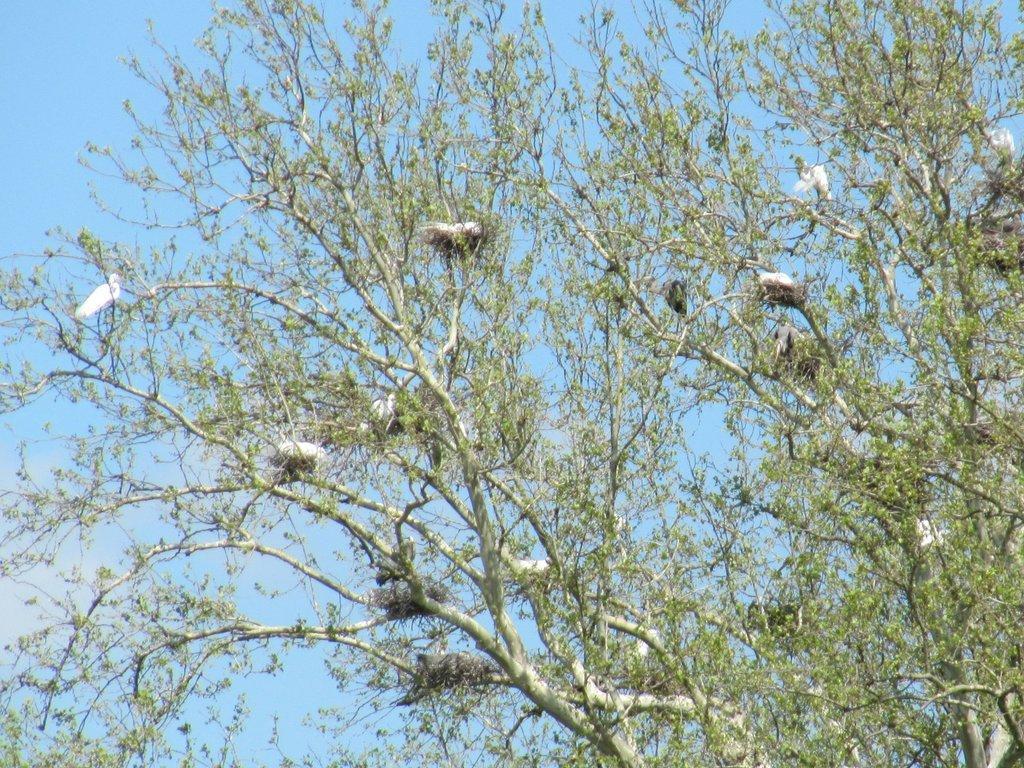Describe this image in one or two sentences. In this image we can see branches of trees. On the branches there are nests and birds. In the background there is sky. 